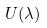<formula> <loc_0><loc_0><loc_500><loc_500>U ( \lambda )</formula> 